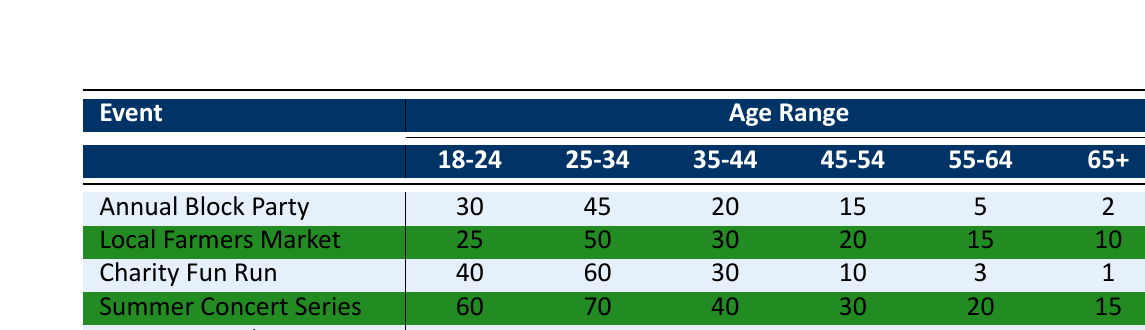What is the total number of participants aged 18-24 at the Summer Concert Series? According to the table, there are 60 participants aged 18-24 for the Summer Concert Series.
Answer: 60 Which event had the highest number of participants aged 65+? The events listed are compared for the 65+ age range: Annual Block Party (2), Local Farmers Market (10), Charity Fun Run (1), Summer Concert Series (15), and Community Clean-Up Day (5). The Summer Concert Series has the highest number of participants aged 65+.
Answer: 15 What is the average number of participants for the 25-34 age range across all events? Adding the participants in the 25-34 age range: (45 + 50 + 60 + 70 + 35) = 260. There are 5 events, so the average is 260/5 = 52.
Answer: 52 Did more participants aged 55-64 attend the Annual Block Party or the Local Farmers Market? Participants aged 55-64 for the Annual Block Party = 5 and for the Local Farmers Market = 15. Since 15 is greater than 5, more participants aged 55-64 attended the Local Farmers Market.
Answer: Yes How many more participants aged 35-44 attended the Charity Fun Run compared to the Community Clean-Up Day? The Charity Fun Run had 30 participants aged 35-44, while the Community Clean-Up Day had 25. The difference is 30 - 25 = 5.
Answer: 5 What is the total number of participants for the event with the least attendance in the 65+ age range? The 65+ age range participation for each event is: Annual Block Party (2), Local Farmers Market (10), Charity Fun Run (1), Summer Concert Series (15), Community Clean-Up Day (5). The event with the least attendance in this age range is the Charity Fun Run with 1 participant.
Answer: 1 Which age range attended the Summer Concert Series the most? The age ranges for the Summer Concert Series are: 18-24 (60), 25-34 (70), 35-44 (40), 45-54 (30), 55-64 (20), 65+ (15). The 25-34 age range had the most participants at 70.
Answer: 25-34 Is the number of participants aged 45-54 greater at the Local Farmers Market than at the Charity Fun Run? Participants aged 45-54 are 20 for the Local Farmers Market and 10 for the Charity Fun Run. Since 20 is greater than 10, participants aged 45-54 are greater at the Local Farmers Market.
Answer: Yes 